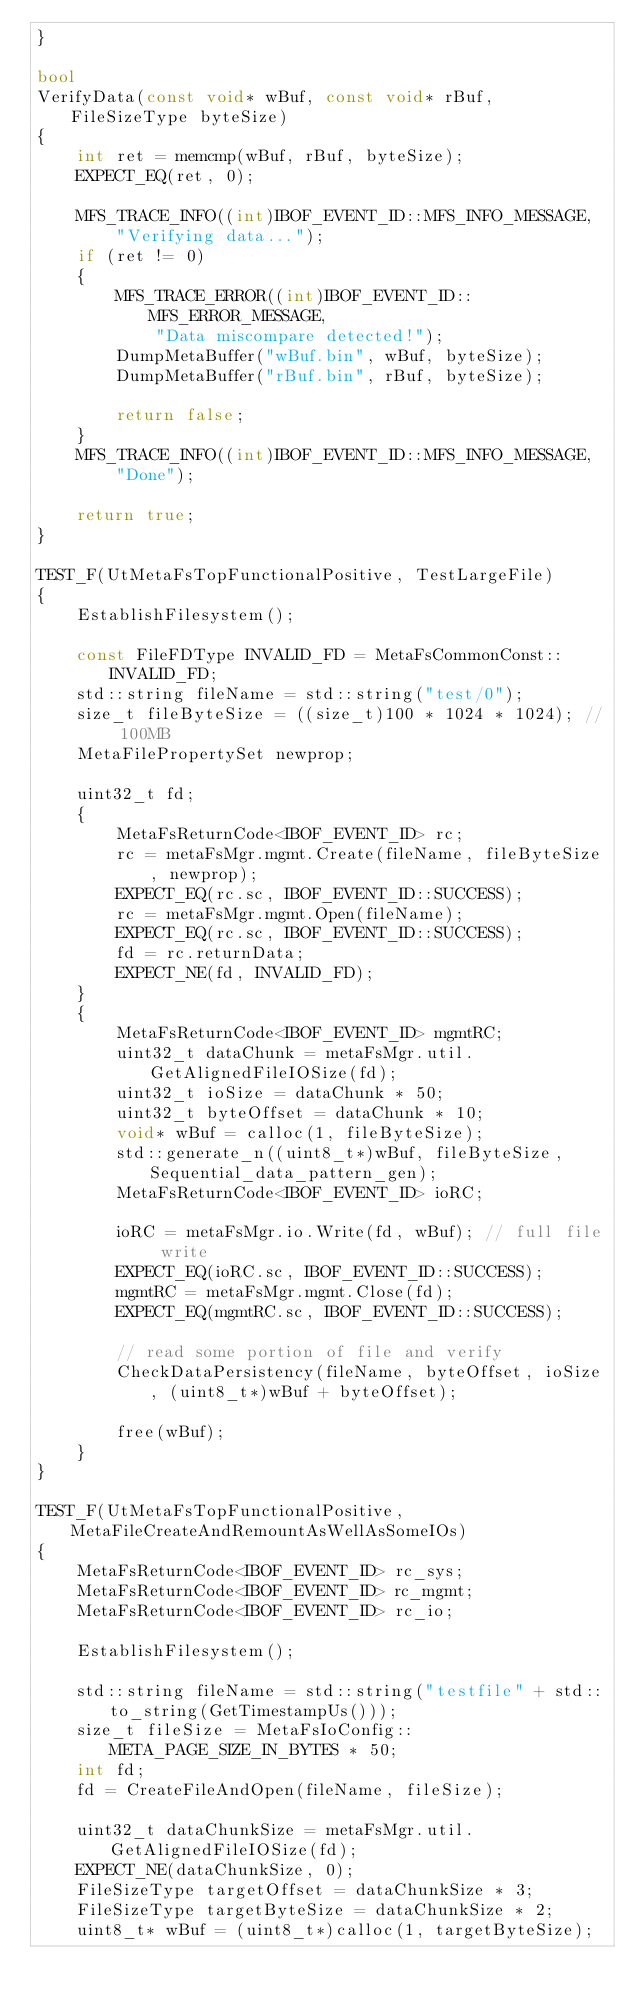<code> <loc_0><loc_0><loc_500><loc_500><_C++_>}

bool
VerifyData(const void* wBuf, const void* rBuf, FileSizeType byteSize)
{
    int ret = memcmp(wBuf, rBuf, byteSize);
    EXPECT_EQ(ret, 0);

    MFS_TRACE_INFO((int)IBOF_EVENT_ID::MFS_INFO_MESSAGE,
        "Verifying data...");
    if (ret != 0)
    {
        MFS_TRACE_ERROR((int)IBOF_EVENT_ID::MFS_ERROR_MESSAGE,
            "Data miscompare detected!");
        DumpMetaBuffer("wBuf.bin", wBuf, byteSize);
        DumpMetaBuffer("rBuf.bin", rBuf, byteSize);

        return false;
    }
    MFS_TRACE_INFO((int)IBOF_EVENT_ID::MFS_INFO_MESSAGE,
        "Done");

    return true;
}

TEST_F(UtMetaFsTopFunctionalPositive, TestLargeFile)
{
    EstablishFilesystem();

    const FileFDType INVALID_FD = MetaFsCommonConst::INVALID_FD;
    std::string fileName = std::string("test/0");
    size_t fileByteSize = ((size_t)100 * 1024 * 1024); // 100MB
    MetaFilePropertySet newprop;

    uint32_t fd;
    {
        MetaFsReturnCode<IBOF_EVENT_ID> rc;
        rc = metaFsMgr.mgmt.Create(fileName, fileByteSize, newprop);
        EXPECT_EQ(rc.sc, IBOF_EVENT_ID::SUCCESS);
        rc = metaFsMgr.mgmt.Open(fileName);
        EXPECT_EQ(rc.sc, IBOF_EVENT_ID::SUCCESS);
        fd = rc.returnData;
        EXPECT_NE(fd, INVALID_FD);
    }
    {
        MetaFsReturnCode<IBOF_EVENT_ID> mgmtRC;
        uint32_t dataChunk = metaFsMgr.util.GetAlignedFileIOSize(fd);
        uint32_t ioSize = dataChunk * 50;
        uint32_t byteOffset = dataChunk * 10;
        void* wBuf = calloc(1, fileByteSize);
        std::generate_n((uint8_t*)wBuf, fileByteSize, Sequential_data_pattern_gen);
        MetaFsReturnCode<IBOF_EVENT_ID> ioRC;

        ioRC = metaFsMgr.io.Write(fd, wBuf); // full file write
        EXPECT_EQ(ioRC.sc, IBOF_EVENT_ID::SUCCESS);
        mgmtRC = metaFsMgr.mgmt.Close(fd);
        EXPECT_EQ(mgmtRC.sc, IBOF_EVENT_ID::SUCCESS);

        // read some portion of file and verify
        CheckDataPersistency(fileName, byteOffset, ioSize, (uint8_t*)wBuf + byteOffset);

        free(wBuf);
    }
}

TEST_F(UtMetaFsTopFunctionalPositive, MetaFileCreateAndRemountAsWellAsSomeIOs)
{
    MetaFsReturnCode<IBOF_EVENT_ID> rc_sys;
    MetaFsReturnCode<IBOF_EVENT_ID> rc_mgmt;
    MetaFsReturnCode<IBOF_EVENT_ID> rc_io;

    EstablishFilesystem();

    std::string fileName = std::string("testfile" + std::to_string(GetTimestampUs()));
    size_t fileSize = MetaFsIoConfig::META_PAGE_SIZE_IN_BYTES * 50;
    int fd;
    fd = CreateFileAndOpen(fileName, fileSize);

    uint32_t dataChunkSize = metaFsMgr.util.GetAlignedFileIOSize(fd);
    EXPECT_NE(dataChunkSize, 0);
    FileSizeType targetOffset = dataChunkSize * 3;
    FileSizeType targetByteSize = dataChunkSize * 2;
    uint8_t* wBuf = (uint8_t*)calloc(1, targetByteSize);</code> 